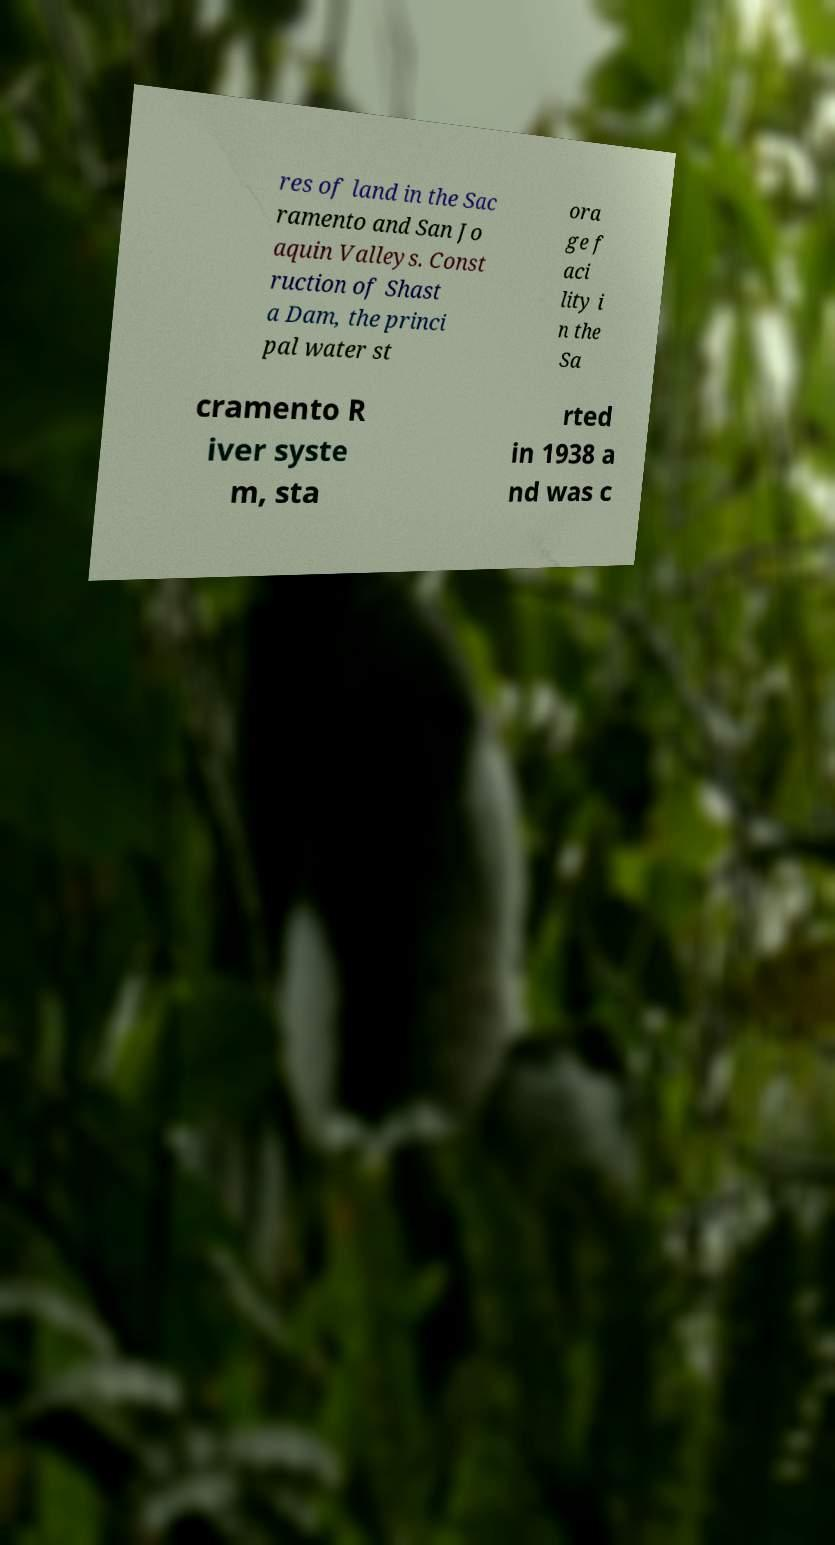Could you extract and type out the text from this image? res of land in the Sac ramento and San Jo aquin Valleys. Const ruction of Shast a Dam, the princi pal water st ora ge f aci lity i n the Sa cramento R iver syste m, sta rted in 1938 a nd was c 